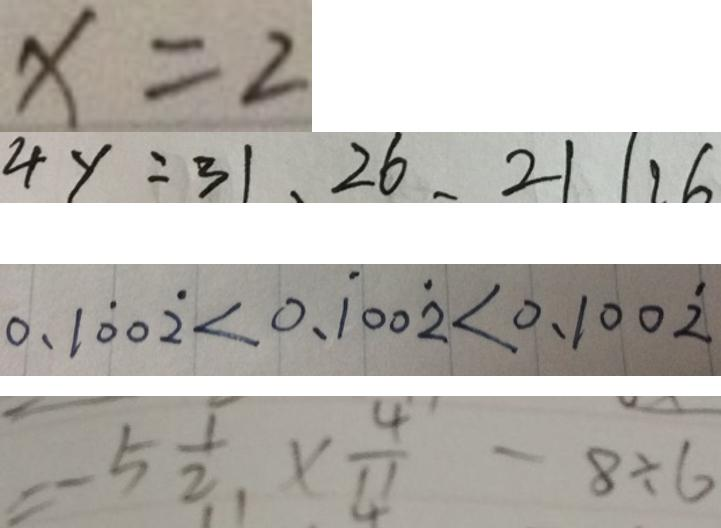Convert formula to latex. <formula><loc_0><loc_0><loc_500><loc_500>x = 2 
 4 y = 3 1 , 2 6 , 2 1 1 1 6 
 0 . 1 \dot { 0 } 0 \dot { 2 } < 0 . \dot { 1 } 0 0 \dot { 2 } < 0 . 1 0 0 \dot { 2 } 
 = - 5 \frac { 1 } { 2 } \times \frac { 4 } { 1 1 } - 8 \div 6</formula> 